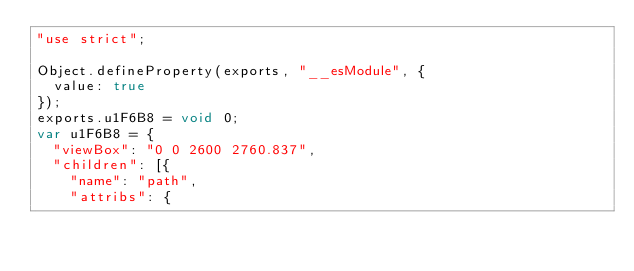Convert code to text. <code><loc_0><loc_0><loc_500><loc_500><_JavaScript_>"use strict";

Object.defineProperty(exports, "__esModule", {
  value: true
});
exports.u1F6B8 = void 0;
var u1F6B8 = {
  "viewBox": "0 0 2600 2760.837",
  "children": [{
    "name": "path",
    "attribs": {</code> 